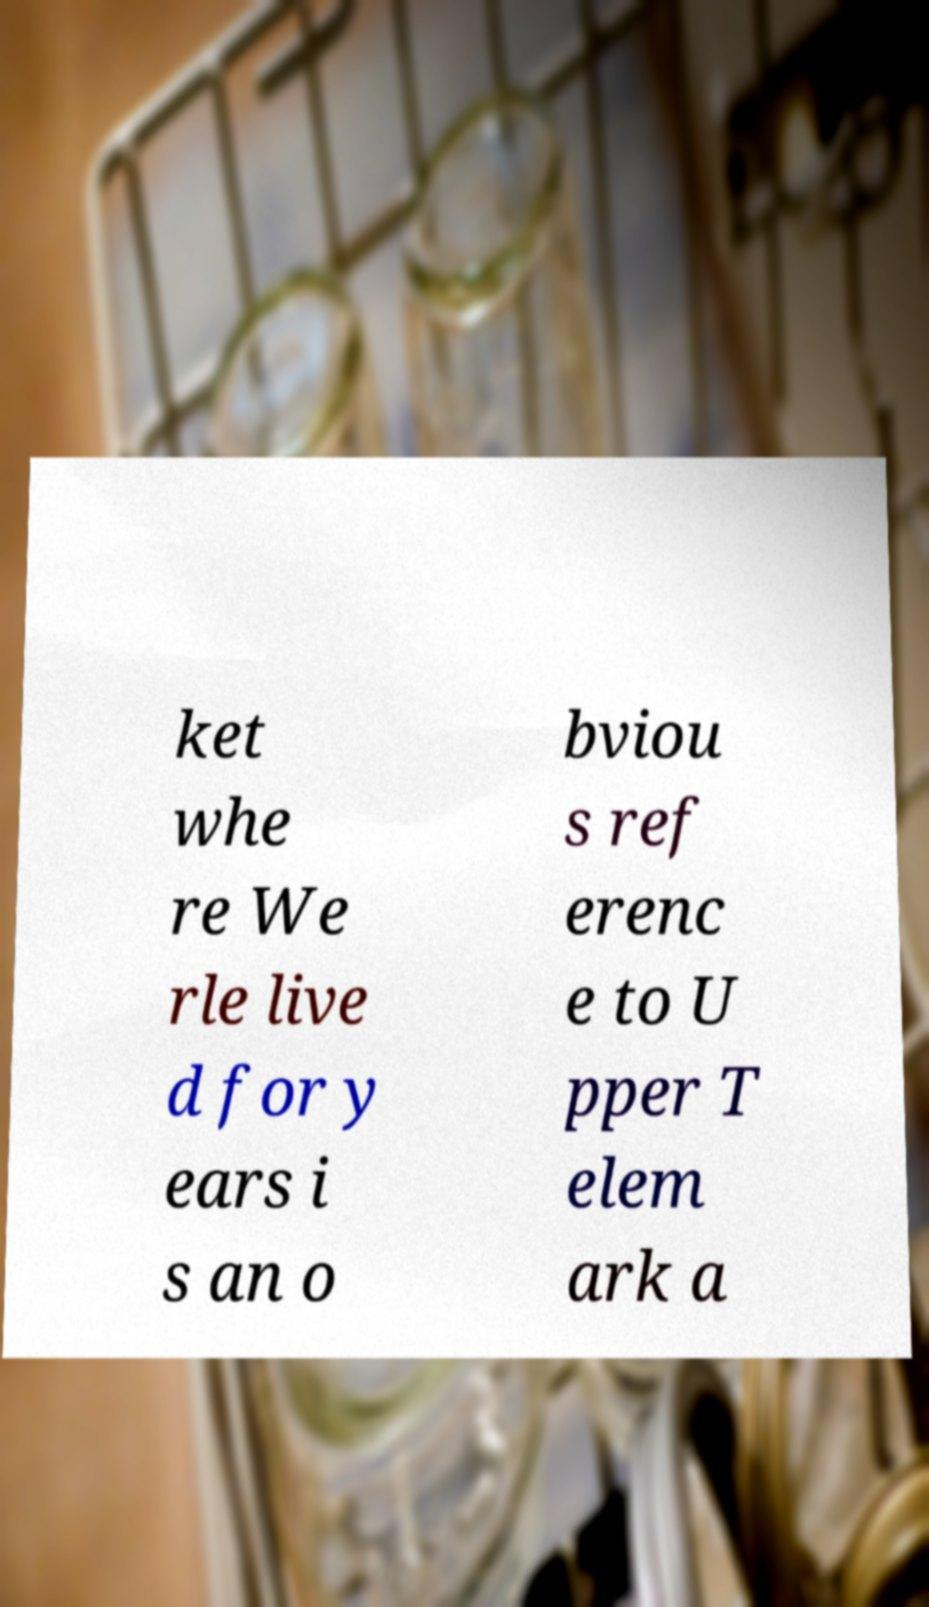I need the written content from this picture converted into text. Can you do that? ket whe re We rle live d for y ears i s an o bviou s ref erenc e to U pper T elem ark a 